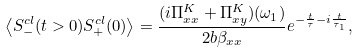<formula> <loc_0><loc_0><loc_500><loc_500>\left \langle S _ { - } ^ { c l } ( t > 0 ) S _ { + } ^ { c l } ( 0 ) \right \rangle = \frac { ( i \Pi _ { x x } ^ { K } + \Pi _ { x y } ^ { K } ) ( \omega _ { 1 } ) } { 2 b \beta _ { x x } } e ^ { - \frac { t } { \tau } - i \frac { t } { \tau _ { 1 } } } ,</formula> 